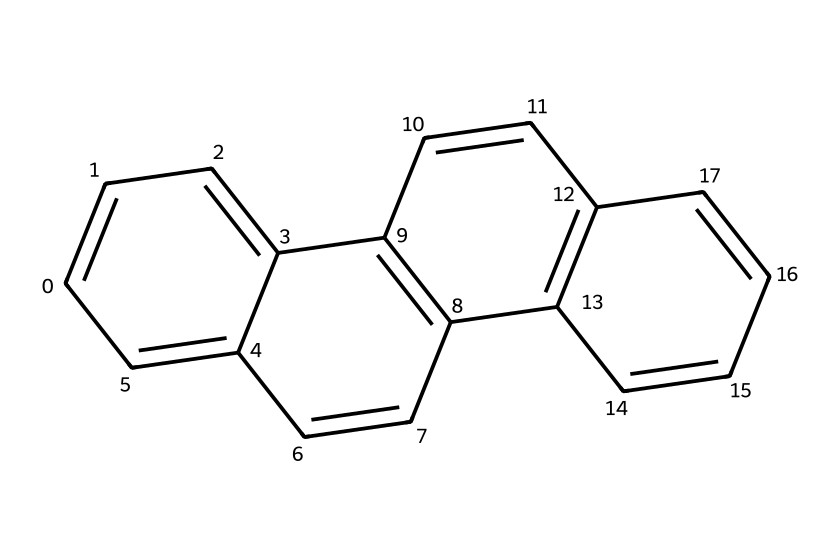What is the main aromatic component in this structure? The structure contains multiple aromatic rings, indicating that it is based on polycyclic aromatic hydrocarbons, with naphthalene being a common component in coal tar.
Answer: naphthalene How many carbon atoms are in this chemical? By analyzing the chemical structure, the total count of carbon atoms can be counted, which shows there are 14 carbon atoms present in the rings.
Answer: 14 What type of compound does this chemical primarily represent? Given the structure's many fused aromatic rings and its presence in coal tar, it is classified as a polycyclic aromatic hydrocarbon (PAH).
Answer: PAH Which chemical feature suggests it might have a strong aroma? The presence of multiple aromatic rings suggests delocalized electrons, which are characteristic of compounds that can produce strong odors, particularly in fragrances.
Answer: aromatic rings How many hydrogen atoms are connected to the carbon framework in this chemical? Each carbon in the rings generally forms 4 bonds; by reasoning through the structure, it is observed there are 8 hydrogen atoms connected to this complex.
Answer: 8 